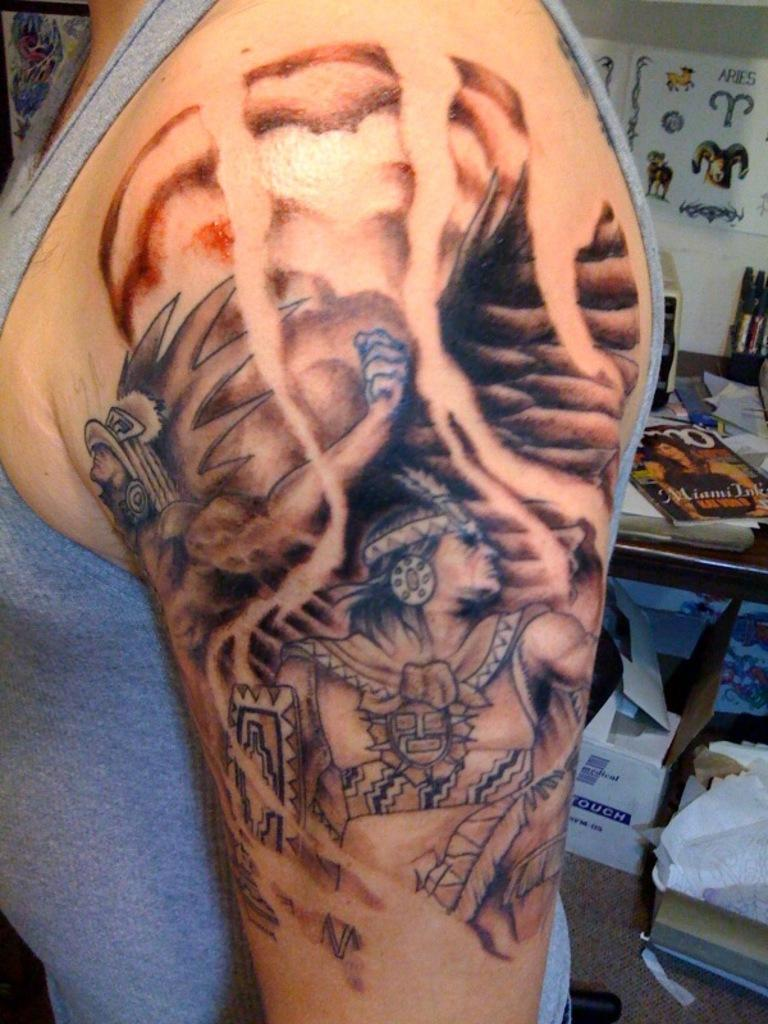What can be seen on the person's hand in the image? There is a tattoo on a person's hand in the image. What type of objects are visible in the background of the image? There are boxes, books, papers, and other objects in the background of the image. What type of jeans is the uncle wearing in the image? There is no uncle or jeans present in the image. Is there a baseball game happening in the background of the image? There is no baseball game or any reference to sports in the image. 